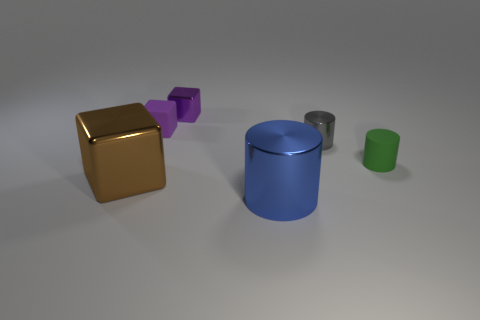There is a large brown block that is left of the metallic cube behind the shiny thing right of the big shiny cylinder; what is it made of?
Your response must be concise. Metal. Are there more brown blocks that are left of the small rubber cylinder than tiny green matte things that are behind the small matte cube?
Keep it short and to the point. Yes. What number of cubes are either brown objects or tiny metal things?
Provide a succinct answer. 2. What number of large brown things are on the left side of the big object that is right of the metallic object to the left of the tiny purple matte object?
Keep it short and to the point. 1. There is a thing that is the same color as the tiny metal block; what is its material?
Offer a terse response. Rubber. Are there more green cylinders than shiny things?
Keep it short and to the point. No. Do the green cylinder and the purple shiny object have the same size?
Provide a succinct answer. Yes. How many objects are red metal balls or small purple cubes?
Ensure brevity in your answer.  2. There is a tiny matte object to the right of the cylinder that is on the left side of the cylinder that is behind the green matte thing; what is its shape?
Offer a terse response. Cylinder. Are the small thing that is in front of the gray shiny object and the large object that is behind the blue shiny thing made of the same material?
Offer a terse response. No. 